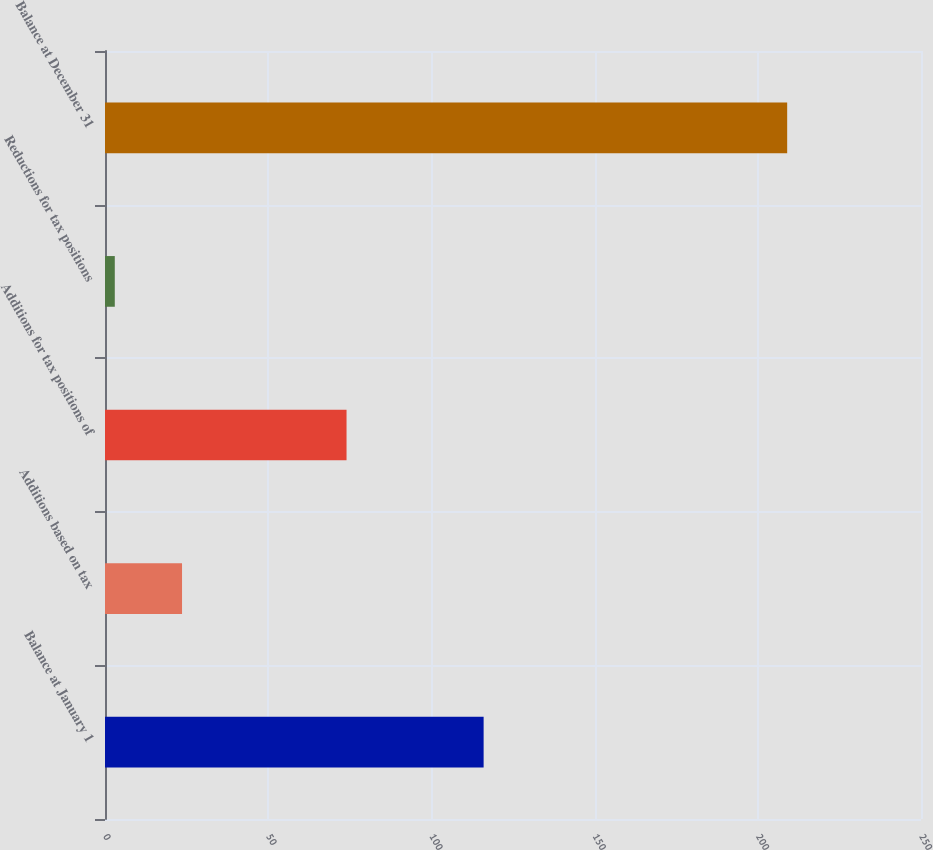<chart> <loc_0><loc_0><loc_500><loc_500><bar_chart><fcel>Balance at January 1<fcel>Additions based on tax<fcel>Additions for tax positions of<fcel>Reductions for tax positions<fcel>Balance at December 31<nl><fcel>116<fcel>23.6<fcel>74<fcel>3<fcel>209<nl></chart> 